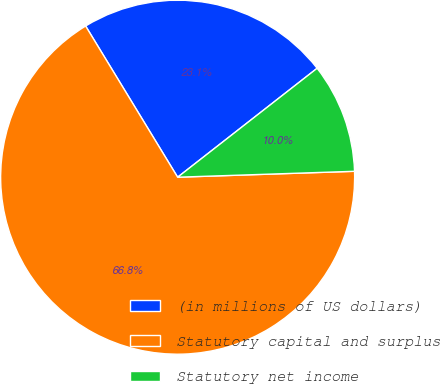Convert chart. <chart><loc_0><loc_0><loc_500><loc_500><pie_chart><fcel>(in millions of US dollars)<fcel>Statutory capital and surplus<fcel>Statutory net income<nl><fcel>23.15%<fcel>66.83%<fcel>10.02%<nl></chart> 